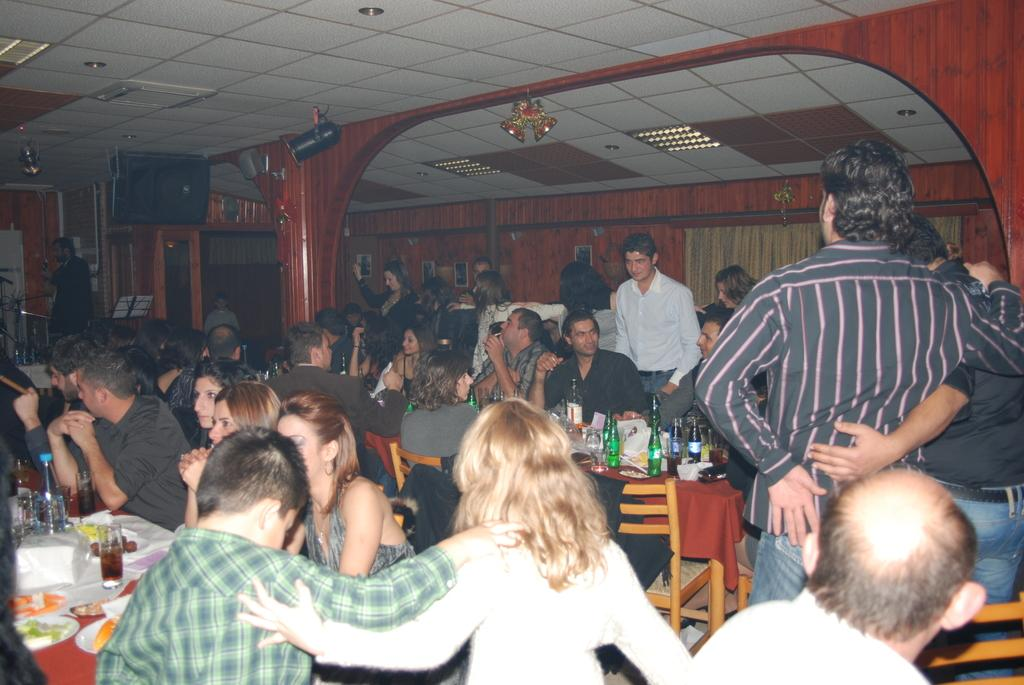What are the people in the image doing? Some people are sitting on chairs, and some are standing in the image. What objects can be seen on the table in the image? There are bottles on a table in the image. What type of behavior is the passenger exhibiting in the image? There is no passenger mentioned in the image, and therefore no behavior can be attributed to a passenger. 